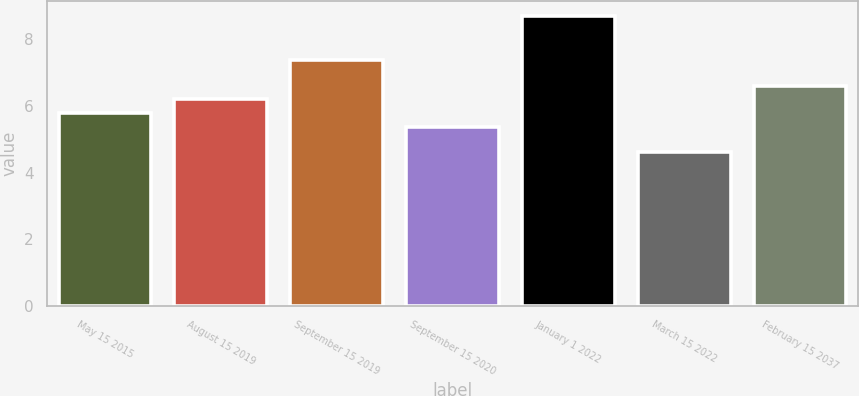Convert chart to OTSL. <chart><loc_0><loc_0><loc_500><loc_500><bar_chart><fcel>May 15 2015<fcel>August 15 2019<fcel>September 15 2019<fcel>September 15 2020<fcel>January 1 2022<fcel>March 15 2022<fcel>February 15 2037<nl><fcel>5.79<fcel>6.2<fcel>7.38<fcel>5.38<fcel>8.7<fcel>4.62<fcel>6.61<nl></chart> 